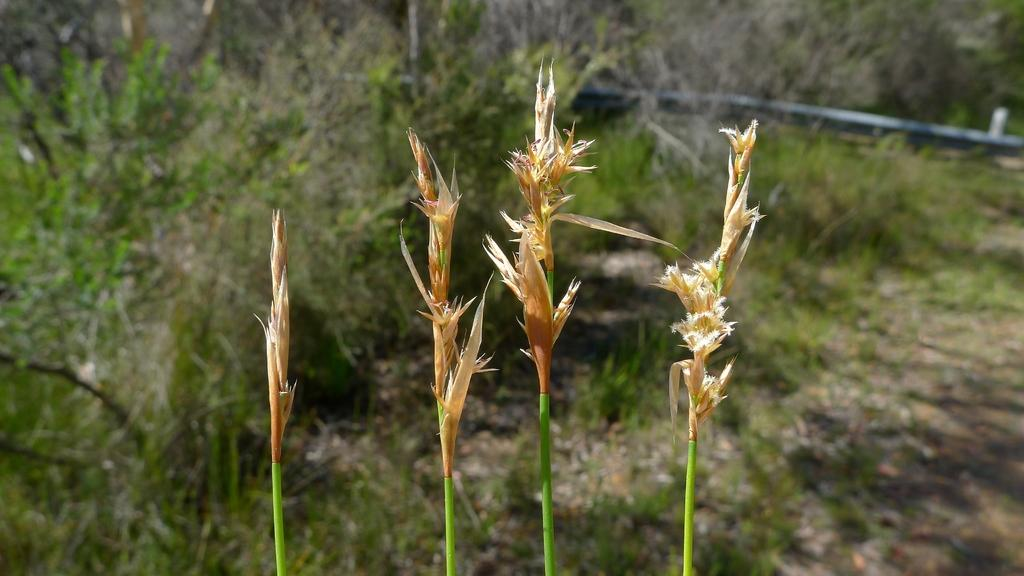What type of vegetation is visible in the image? There is grass in the image. What can be seen in the background of the image? There are plants in the background of the image. What object is on the ground in the image? There is a pipe on the ground in the image. How many passengers are on the sail in the image? There is no sail or passengers present in the image. 